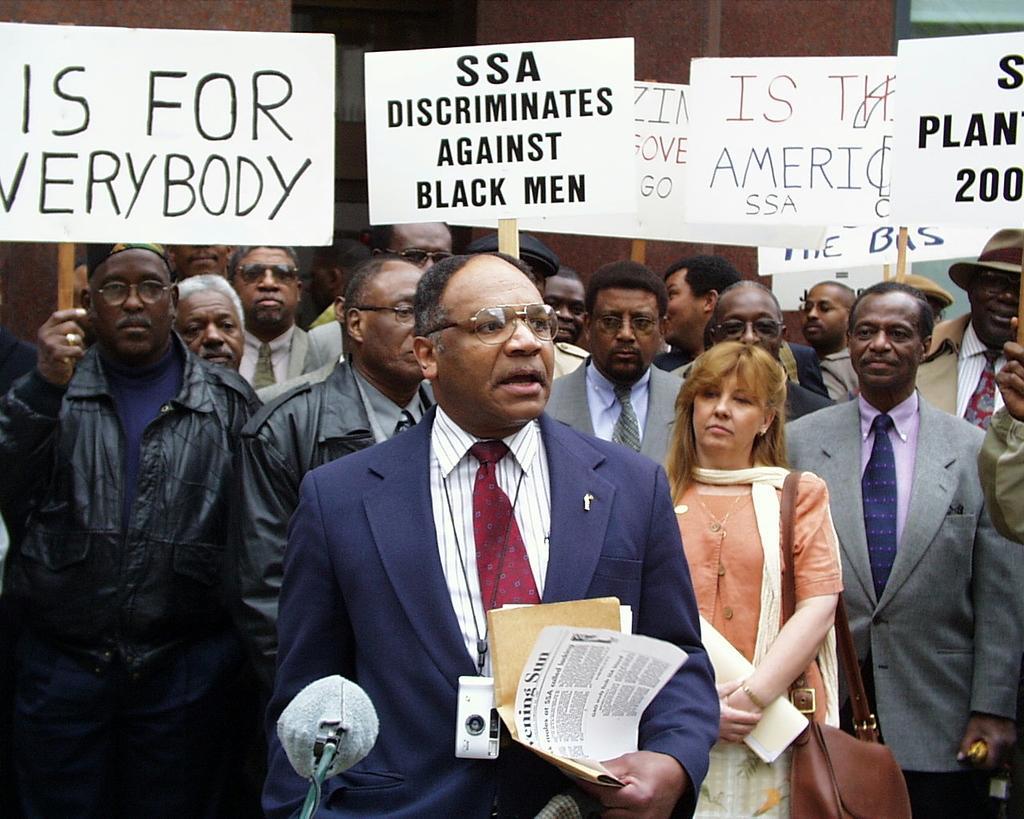In one or two sentences, can you explain what this image depicts? In the front of the image I can see people and an object. Among these people one person is holding papers and worn camera. A woman is holding an object and wire bag. Few people are holding boards. In the background of the image I can see a pillar. 